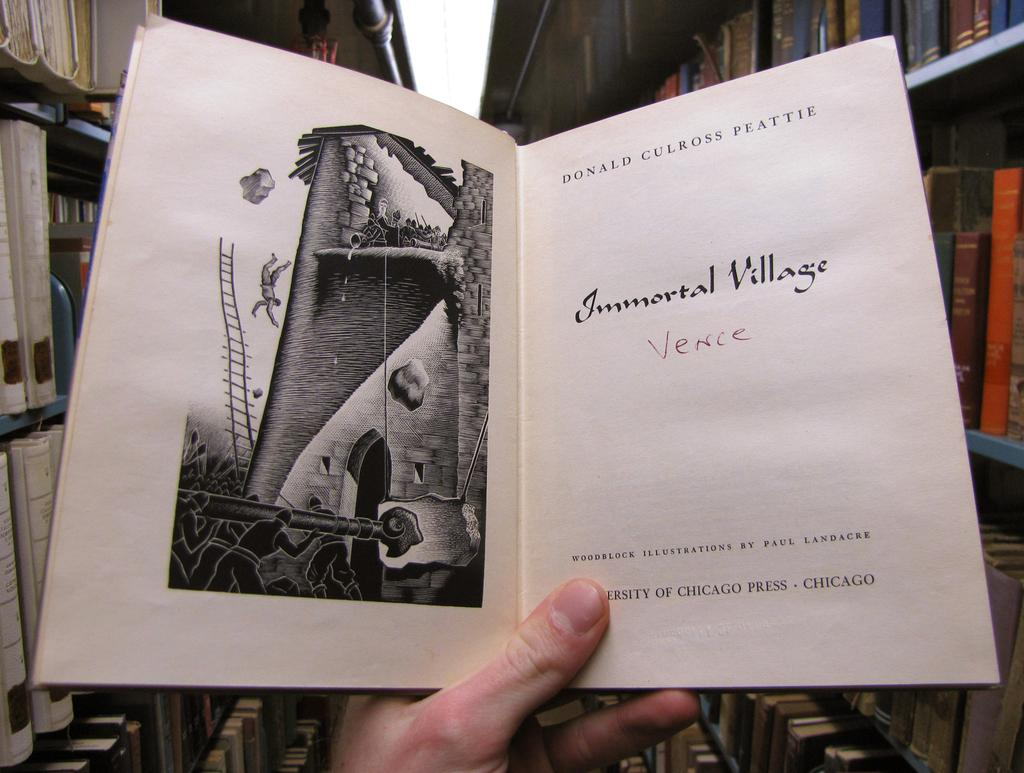What is being held by the hand in the image? There is a hand holding a book on the right side of the image. What can be seen on the left side of the image? There are shelves on the left side of the image. What is stored on the shelves? The shelves contain books. What type of blade is being used for cutting the books on the shelves? There is no blade present in the image, and the books are not being cut. What observation can be made about the base of the shelves in the image? There is no information provided about the base of the shelves, so no observation can be made. 